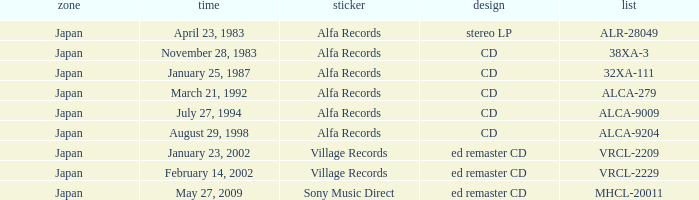Which identifier is associated with february 14, 2002? Village Records. 